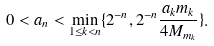<formula> <loc_0><loc_0><loc_500><loc_500>0 < a _ { n } < \min _ { 1 \leq k < n } \{ 2 ^ { - n } , 2 ^ { - n } \frac { a _ { k } m _ { k } } { 4 M _ { m _ { k } } } \} .</formula> 